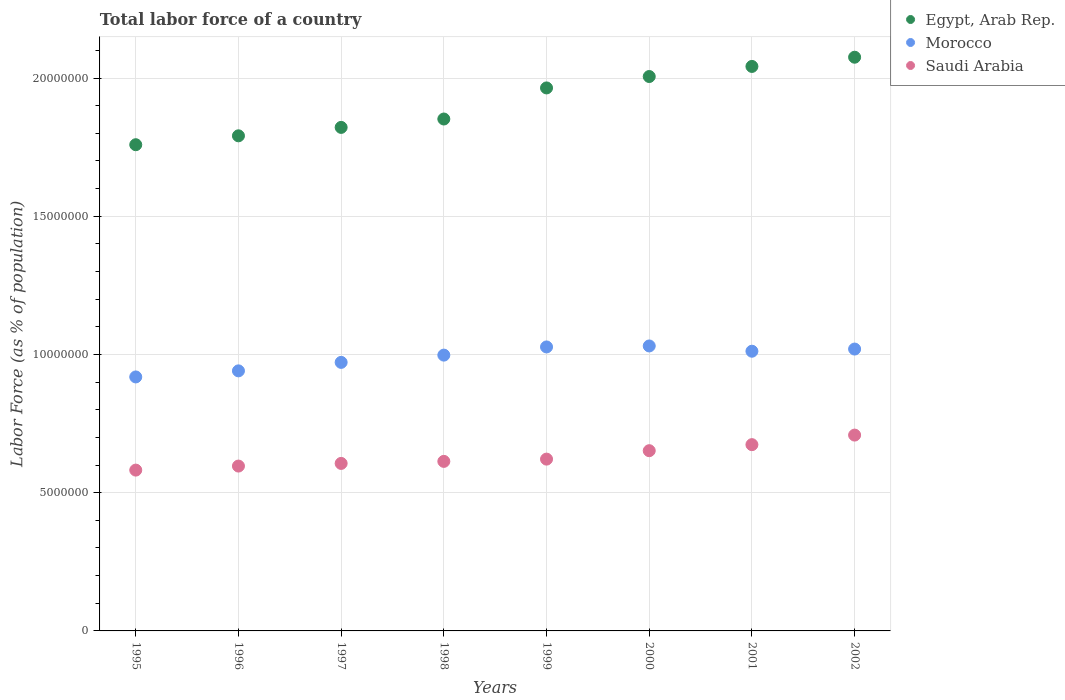What is the percentage of labor force in Saudi Arabia in 2002?
Your answer should be compact. 7.08e+06. Across all years, what is the maximum percentage of labor force in Saudi Arabia?
Make the answer very short. 7.08e+06. Across all years, what is the minimum percentage of labor force in Saudi Arabia?
Your answer should be very brief. 5.82e+06. In which year was the percentage of labor force in Egypt, Arab Rep. maximum?
Make the answer very short. 2002. What is the total percentage of labor force in Saudi Arabia in the graph?
Provide a short and direct response. 5.05e+07. What is the difference between the percentage of labor force in Morocco in 1999 and that in 2000?
Make the answer very short. -3.57e+04. What is the difference between the percentage of labor force in Morocco in 2002 and the percentage of labor force in Egypt, Arab Rep. in 1997?
Keep it short and to the point. -8.02e+06. What is the average percentage of labor force in Egypt, Arab Rep. per year?
Your answer should be very brief. 1.91e+07. In the year 2001, what is the difference between the percentage of labor force in Saudi Arabia and percentage of labor force in Morocco?
Your response must be concise. -3.38e+06. In how many years, is the percentage of labor force in Morocco greater than 1000000 %?
Your answer should be very brief. 8. What is the ratio of the percentage of labor force in Saudi Arabia in 1998 to that in 2002?
Make the answer very short. 0.87. Is the percentage of labor force in Morocco in 2000 less than that in 2002?
Provide a short and direct response. No. What is the difference between the highest and the second highest percentage of labor force in Morocco?
Offer a terse response. 3.57e+04. What is the difference between the highest and the lowest percentage of labor force in Saudi Arabia?
Provide a short and direct response. 1.27e+06. In how many years, is the percentage of labor force in Egypt, Arab Rep. greater than the average percentage of labor force in Egypt, Arab Rep. taken over all years?
Provide a short and direct response. 4. Is it the case that in every year, the sum of the percentage of labor force in Egypt, Arab Rep. and percentage of labor force in Morocco  is greater than the percentage of labor force in Saudi Arabia?
Give a very brief answer. Yes. Does the percentage of labor force in Morocco monotonically increase over the years?
Provide a succinct answer. No. Is the percentage of labor force in Egypt, Arab Rep. strictly less than the percentage of labor force in Morocco over the years?
Keep it short and to the point. No. How many dotlines are there?
Offer a terse response. 3. Are the values on the major ticks of Y-axis written in scientific E-notation?
Ensure brevity in your answer.  No. Does the graph contain any zero values?
Give a very brief answer. No. Does the graph contain grids?
Your response must be concise. Yes. Where does the legend appear in the graph?
Offer a terse response. Top right. What is the title of the graph?
Provide a succinct answer. Total labor force of a country. What is the label or title of the Y-axis?
Offer a very short reply. Labor Force (as % of population). What is the Labor Force (as % of population) of Egypt, Arab Rep. in 1995?
Provide a succinct answer. 1.76e+07. What is the Labor Force (as % of population) in Morocco in 1995?
Offer a terse response. 9.19e+06. What is the Labor Force (as % of population) of Saudi Arabia in 1995?
Offer a terse response. 5.82e+06. What is the Labor Force (as % of population) in Egypt, Arab Rep. in 1996?
Ensure brevity in your answer.  1.79e+07. What is the Labor Force (as % of population) of Morocco in 1996?
Offer a terse response. 9.41e+06. What is the Labor Force (as % of population) of Saudi Arabia in 1996?
Offer a very short reply. 5.96e+06. What is the Labor Force (as % of population) in Egypt, Arab Rep. in 1997?
Keep it short and to the point. 1.82e+07. What is the Labor Force (as % of population) of Morocco in 1997?
Provide a short and direct response. 9.71e+06. What is the Labor Force (as % of population) of Saudi Arabia in 1997?
Keep it short and to the point. 6.06e+06. What is the Labor Force (as % of population) in Egypt, Arab Rep. in 1998?
Give a very brief answer. 1.85e+07. What is the Labor Force (as % of population) of Morocco in 1998?
Provide a succinct answer. 9.98e+06. What is the Labor Force (as % of population) in Saudi Arabia in 1998?
Provide a succinct answer. 6.13e+06. What is the Labor Force (as % of population) in Egypt, Arab Rep. in 1999?
Your answer should be very brief. 1.96e+07. What is the Labor Force (as % of population) in Morocco in 1999?
Keep it short and to the point. 1.03e+07. What is the Labor Force (as % of population) in Saudi Arabia in 1999?
Your response must be concise. 6.21e+06. What is the Labor Force (as % of population) of Egypt, Arab Rep. in 2000?
Your response must be concise. 2.01e+07. What is the Labor Force (as % of population) of Morocco in 2000?
Offer a terse response. 1.03e+07. What is the Labor Force (as % of population) of Saudi Arabia in 2000?
Keep it short and to the point. 6.52e+06. What is the Labor Force (as % of population) of Egypt, Arab Rep. in 2001?
Provide a succinct answer. 2.04e+07. What is the Labor Force (as % of population) of Morocco in 2001?
Offer a very short reply. 1.01e+07. What is the Labor Force (as % of population) in Saudi Arabia in 2001?
Offer a very short reply. 6.74e+06. What is the Labor Force (as % of population) of Egypt, Arab Rep. in 2002?
Offer a very short reply. 2.08e+07. What is the Labor Force (as % of population) in Morocco in 2002?
Offer a terse response. 1.02e+07. What is the Labor Force (as % of population) of Saudi Arabia in 2002?
Your answer should be very brief. 7.08e+06. Across all years, what is the maximum Labor Force (as % of population) in Egypt, Arab Rep.?
Offer a terse response. 2.08e+07. Across all years, what is the maximum Labor Force (as % of population) of Morocco?
Keep it short and to the point. 1.03e+07. Across all years, what is the maximum Labor Force (as % of population) of Saudi Arabia?
Keep it short and to the point. 7.08e+06. Across all years, what is the minimum Labor Force (as % of population) in Egypt, Arab Rep.?
Provide a short and direct response. 1.76e+07. Across all years, what is the minimum Labor Force (as % of population) in Morocco?
Your answer should be very brief. 9.19e+06. Across all years, what is the minimum Labor Force (as % of population) in Saudi Arabia?
Your response must be concise. 5.82e+06. What is the total Labor Force (as % of population) in Egypt, Arab Rep. in the graph?
Your answer should be very brief. 1.53e+08. What is the total Labor Force (as % of population) in Morocco in the graph?
Provide a short and direct response. 7.92e+07. What is the total Labor Force (as % of population) in Saudi Arabia in the graph?
Provide a short and direct response. 5.05e+07. What is the difference between the Labor Force (as % of population) in Egypt, Arab Rep. in 1995 and that in 1996?
Give a very brief answer. -3.22e+05. What is the difference between the Labor Force (as % of population) of Morocco in 1995 and that in 1996?
Give a very brief answer. -2.20e+05. What is the difference between the Labor Force (as % of population) in Saudi Arabia in 1995 and that in 1996?
Provide a short and direct response. -1.46e+05. What is the difference between the Labor Force (as % of population) of Egypt, Arab Rep. in 1995 and that in 1997?
Give a very brief answer. -6.27e+05. What is the difference between the Labor Force (as % of population) in Morocco in 1995 and that in 1997?
Make the answer very short. -5.27e+05. What is the difference between the Labor Force (as % of population) of Saudi Arabia in 1995 and that in 1997?
Your answer should be very brief. -2.42e+05. What is the difference between the Labor Force (as % of population) in Egypt, Arab Rep. in 1995 and that in 1998?
Your answer should be very brief. -9.30e+05. What is the difference between the Labor Force (as % of population) of Morocco in 1995 and that in 1998?
Your answer should be very brief. -7.89e+05. What is the difference between the Labor Force (as % of population) in Saudi Arabia in 1995 and that in 1998?
Your answer should be compact. -3.16e+05. What is the difference between the Labor Force (as % of population) in Egypt, Arab Rep. in 1995 and that in 1999?
Your answer should be compact. -2.05e+06. What is the difference between the Labor Force (as % of population) in Morocco in 1995 and that in 1999?
Offer a very short reply. -1.08e+06. What is the difference between the Labor Force (as % of population) of Saudi Arabia in 1995 and that in 1999?
Your response must be concise. -3.97e+05. What is the difference between the Labor Force (as % of population) of Egypt, Arab Rep. in 1995 and that in 2000?
Offer a very short reply. -2.47e+06. What is the difference between the Labor Force (as % of population) of Morocco in 1995 and that in 2000?
Your answer should be very brief. -1.12e+06. What is the difference between the Labor Force (as % of population) of Saudi Arabia in 1995 and that in 2000?
Your answer should be compact. -7.02e+05. What is the difference between the Labor Force (as % of population) of Egypt, Arab Rep. in 1995 and that in 2001?
Ensure brevity in your answer.  -2.83e+06. What is the difference between the Labor Force (as % of population) of Morocco in 1995 and that in 2001?
Offer a terse response. -9.30e+05. What is the difference between the Labor Force (as % of population) in Saudi Arabia in 1995 and that in 2001?
Give a very brief answer. -9.21e+05. What is the difference between the Labor Force (as % of population) in Egypt, Arab Rep. in 1995 and that in 2002?
Your answer should be compact. -3.17e+06. What is the difference between the Labor Force (as % of population) in Morocco in 1995 and that in 2002?
Your answer should be very brief. -1.01e+06. What is the difference between the Labor Force (as % of population) of Saudi Arabia in 1995 and that in 2002?
Your answer should be very brief. -1.27e+06. What is the difference between the Labor Force (as % of population) in Egypt, Arab Rep. in 1996 and that in 1997?
Keep it short and to the point. -3.05e+05. What is the difference between the Labor Force (as % of population) of Morocco in 1996 and that in 1997?
Offer a very short reply. -3.07e+05. What is the difference between the Labor Force (as % of population) in Saudi Arabia in 1996 and that in 1997?
Provide a succinct answer. -9.58e+04. What is the difference between the Labor Force (as % of population) in Egypt, Arab Rep. in 1996 and that in 1998?
Provide a short and direct response. -6.08e+05. What is the difference between the Labor Force (as % of population) of Morocco in 1996 and that in 1998?
Give a very brief answer. -5.70e+05. What is the difference between the Labor Force (as % of population) in Saudi Arabia in 1996 and that in 1998?
Your answer should be compact. -1.69e+05. What is the difference between the Labor Force (as % of population) in Egypt, Arab Rep. in 1996 and that in 1999?
Keep it short and to the point. -1.73e+06. What is the difference between the Labor Force (as % of population) of Morocco in 1996 and that in 1999?
Keep it short and to the point. -8.65e+05. What is the difference between the Labor Force (as % of population) of Saudi Arabia in 1996 and that in 1999?
Offer a very short reply. -2.51e+05. What is the difference between the Labor Force (as % of population) of Egypt, Arab Rep. in 1996 and that in 2000?
Offer a very short reply. -2.14e+06. What is the difference between the Labor Force (as % of population) of Morocco in 1996 and that in 2000?
Your answer should be compact. -9.01e+05. What is the difference between the Labor Force (as % of population) in Saudi Arabia in 1996 and that in 2000?
Provide a short and direct response. -5.56e+05. What is the difference between the Labor Force (as % of population) of Egypt, Arab Rep. in 1996 and that in 2001?
Offer a terse response. -2.51e+06. What is the difference between the Labor Force (as % of population) of Morocco in 1996 and that in 2001?
Provide a short and direct response. -7.10e+05. What is the difference between the Labor Force (as % of population) of Saudi Arabia in 1996 and that in 2001?
Provide a succinct answer. -7.75e+05. What is the difference between the Labor Force (as % of population) of Egypt, Arab Rep. in 1996 and that in 2002?
Provide a succinct answer. -2.84e+06. What is the difference between the Labor Force (as % of population) of Morocco in 1996 and that in 2002?
Make the answer very short. -7.89e+05. What is the difference between the Labor Force (as % of population) of Saudi Arabia in 1996 and that in 2002?
Make the answer very short. -1.12e+06. What is the difference between the Labor Force (as % of population) in Egypt, Arab Rep. in 1997 and that in 1998?
Ensure brevity in your answer.  -3.03e+05. What is the difference between the Labor Force (as % of population) in Morocco in 1997 and that in 1998?
Offer a terse response. -2.63e+05. What is the difference between the Labor Force (as % of population) in Saudi Arabia in 1997 and that in 1998?
Your answer should be compact. -7.36e+04. What is the difference between the Labor Force (as % of population) in Egypt, Arab Rep. in 1997 and that in 1999?
Your answer should be very brief. -1.43e+06. What is the difference between the Labor Force (as % of population) in Morocco in 1997 and that in 1999?
Give a very brief answer. -5.58e+05. What is the difference between the Labor Force (as % of population) in Saudi Arabia in 1997 and that in 1999?
Make the answer very short. -1.55e+05. What is the difference between the Labor Force (as % of population) of Egypt, Arab Rep. in 1997 and that in 2000?
Make the answer very short. -1.84e+06. What is the difference between the Labor Force (as % of population) of Morocco in 1997 and that in 2000?
Your answer should be very brief. -5.94e+05. What is the difference between the Labor Force (as % of population) in Saudi Arabia in 1997 and that in 2000?
Keep it short and to the point. -4.60e+05. What is the difference between the Labor Force (as % of population) in Egypt, Arab Rep. in 1997 and that in 2001?
Offer a terse response. -2.21e+06. What is the difference between the Labor Force (as % of population) in Morocco in 1997 and that in 2001?
Offer a terse response. -4.04e+05. What is the difference between the Labor Force (as % of population) in Saudi Arabia in 1997 and that in 2001?
Your answer should be compact. -6.79e+05. What is the difference between the Labor Force (as % of population) in Egypt, Arab Rep. in 1997 and that in 2002?
Your answer should be very brief. -2.54e+06. What is the difference between the Labor Force (as % of population) in Morocco in 1997 and that in 2002?
Your answer should be very brief. -4.82e+05. What is the difference between the Labor Force (as % of population) in Saudi Arabia in 1997 and that in 2002?
Give a very brief answer. -1.02e+06. What is the difference between the Labor Force (as % of population) in Egypt, Arab Rep. in 1998 and that in 1999?
Provide a succinct answer. -1.12e+06. What is the difference between the Labor Force (as % of population) of Morocco in 1998 and that in 1999?
Offer a very short reply. -2.95e+05. What is the difference between the Labor Force (as % of population) in Saudi Arabia in 1998 and that in 1999?
Your answer should be compact. -8.19e+04. What is the difference between the Labor Force (as % of population) in Egypt, Arab Rep. in 1998 and that in 2000?
Your answer should be compact. -1.54e+06. What is the difference between the Labor Force (as % of population) of Morocco in 1998 and that in 2000?
Make the answer very short. -3.31e+05. What is the difference between the Labor Force (as % of population) of Saudi Arabia in 1998 and that in 2000?
Your answer should be very brief. -3.87e+05. What is the difference between the Labor Force (as % of population) of Egypt, Arab Rep. in 1998 and that in 2001?
Provide a succinct answer. -1.90e+06. What is the difference between the Labor Force (as % of population) in Morocco in 1998 and that in 2001?
Offer a terse response. -1.41e+05. What is the difference between the Labor Force (as % of population) in Saudi Arabia in 1998 and that in 2001?
Offer a terse response. -6.05e+05. What is the difference between the Labor Force (as % of population) of Egypt, Arab Rep. in 1998 and that in 2002?
Your response must be concise. -2.24e+06. What is the difference between the Labor Force (as % of population) of Morocco in 1998 and that in 2002?
Provide a short and direct response. -2.19e+05. What is the difference between the Labor Force (as % of population) of Saudi Arabia in 1998 and that in 2002?
Provide a succinct answer. -9.51e+05. What is the difference between the Labor Force (as % of population) in Egypt, Arab Rep. in 1999 and that in 2000?
Your response must be concise. -4.13e+05. What is the difference between the Labor Force (as % of population) in Morocco in 1999 and that in 2000?
Give a very brief answer. -3.57e+04. What is the difference between the Labor Force (as % of population) of Saudi Arabia in 1999 and that in 2000?
Offer a very short reply. -3.05e+05. What is the difference between the Labor Force (as % of population) in Egypt, Arab Rep. in 1999 and that in 2001?
Offer a terse response. -7.78e+05. What is the difference between the Labor Force (as % of population) in Morocco in 1999 and that in 2001?
Make the answer very short. 1.55e+05. What is the difference between the Labor Force (as % of population) of Saudi Arabia in 1999 and that in 2001?
Make the answer very short. -5.23e+05. What is the difference between the Labor Force (as % of population) in Egypt, Arab Rep. in 1999 and that in 2002?
Provide a succinct answer. -1.11e+06. What is the difference between the Labor Force (as % of population) of Morocco in 1999 and that in 2002?
Your answer should be very brief. 7.62e+04. What is the difference between the Labor Force (as % of population) of Saudi Arabia in 1999 and that in 2002?
Your response must be concise. -8.69e+05. What is the difference between the Labor Force (as % of population) in Egypt, Arab Rep. in 2000 and that in 2001?
Your answer should be very brief. -3.65e+05. What is the difference between the Labor Force (as % of population) of Morocco in 2000 and that in 2001?
Keep it short and to the point. 1.90e+05. What is the difference between the Labor Force (as % of population) in Saudi Arabia in 2000 and that in 2001?
Give a very brief answer. -2.18e+05. What is the difference between the Labor Force (as % of population) in Egypt, Arab Rep. in 2000 and that in 2002?
Give a very brief answer. -6.98e+05. What is the difference between the Labor Force (as % of population) in Morocco in 2000 and that in 2002?
Ensure brevity in your answer.  1.12e+05. What is the difference between the Labor Force (as % of population) of Saudi Arabia in 2000 and that in 2002?
Your answer should be compact. -5.64e+05. What is the difference between the Labor Force (as % of population) in Egypt, Arab Rep. in 2001 and that in 2002?
Provide a short and direct response. -3.33e+05. What is the difference between the Labor Force (as % of population) in Morocco in 2001 and that in 2002?
Provide a succinct answer. -7.84e+04. What is the difference between the Labor Force (as % of population) in Saudi Arabia in 2001 and that in 2002?
Your response must be concise. -3.46e+05. What is the difference between the Labor Force (as % of population) in Egypt, Arab Rep. in 1995 and the Labor Force (as % of population) in Morocco in 1996?
Ensure brevity in your answer.  8.18e+06. What is the difference between the Labor Force (as % of population) in Egypt, Arab Rep. in 1995 and the Labor Force (as % of population) in Saudi Arabia in 1996?
Provide a short and direct response. 1.16e+07. What is the difference between the Labor Force (as % of population) in Morocco in 1995 and the Labor Force (as % of population) in Saudi Arabia in 1996?
Provide a succinct answer. 3.22e+06. What is the difference between the Labor Force (as % of population) in Egypt, Arab Rep. in 1995 and the Labor Force (as % of population) in Morocco in 1997?
Offer a terse response. 7.87e+06. What is the difference between the Labor Force (as % of population) of Egypt, Arab Rep. in 1995 and the Labor Force (as % of population) of Saudi Arabia in 1997?
Ensure brevity in your answer.  1.15e+07. What is the difference between the Labor Force (as % of population) in Morocco in 1995 and the Labor Force (as % of population) in Saudi Arabia in 1997?
Make the answer very short. 3.13e+06. What is the difference between the Labor Force (as % of population) in Egypt, Arab Rep. in 1995 and the Labor Force (as % of population) in Morocco in 1998?
Ensure brevity in your answer.  7.61e+06. What is the difference between the Labor Force (as % of population) of Egypt, Arab Rep. in 1995 and the Labor Force (as % of population) of Saudi Arabia in 1998?
Provide a short and direct response. 1.15e+07. What is the difference between the Labor Force (as % of population) of Morocco in 1995 and the Labor Force (as % of population) of Saudi Arabia in 1998?
Your answer should be very brief. 3.05e+06. What is the difference between the Labor Force (as % of population) in Egypt, Arab Rep. in 1995 and the Labor Force (as % of population) in Morocco in 1999?
Provide a succinct answer. 7.32e+06. What is the difference between the Labor Force (as % of population) of Egypt, Arab Rep. in 1995 and the Labor Force (as % of population) of Saudi Arabia in 1999?
Your answer should be compact. 1.14e+07. What is the difference between the Labor Force (as % of population) of Morocco in 1995 and the Labor Force (as % of population) of Saudi Arabia in 1999?
Your response must be concise. 2.97e+06. What is the difference between the Labor Force (as % of population) in Egypt, Arab Rep. in 1995 and the Labor Force (as % of population) in Morocco in 2000?
Ensure brevity in your answer.  7.28e+06. What is the difference between the Labor Force (as % of population) of Egypt, Arab Rep. in 1995 and the Labor Force (as % of population) of Saudi Arabia in 2000?
Provide a short and direct response. 1.11e+07. What is the difference between the Labor Force (as % of population) of Morocco in 1995 and the Labor Force (as % of population) of Saudi Arabia in 2000?
Make the answer very short. 2.67e+06. What is the difference between the Labor Force (as % of population) in Egypt, Arab Rep. in 1995 and the Labor Force (as % of population) in Morocco in 2001?
Offer a very short reply. 7.47e+06. What is the difference between the Labor Force (as % of population) in Egypt, Arab Rep. in 1995 and the Labor Force (as % of population) in Saudi Arabia in 2001?
Ensure brevity in your answer.  1.09e+07. What is the difference between the Labor Force (as % of population) in Morocco in 1995 and the Labor Force (as % of population) in Saudi Arabia in 2001?
Ensure brevity in your answer.  2.45e+06. What is the difference between the Labor Force (as % of population) of Egypt, Arab Rep. in 1995 and the Labor Force (as % of population) of Morocco in 2002?
Give a very brief answer. 7.39e+06. What is the difference between the Labor Force (as % of population) in Egypt, Arab Rep. in 1995 and the Labor Force (as % of population) in Saudi Arabia in 2002?
Give a very brief answer. 1.05e+07. What is the difference between the Labor Force (as % of population) of Morocco in 1995 and the Labor Force (as % of population) of Saudi Arabia in 2002?
Give a very brief answer. 2.10e+06. What is the difference between the Labor Force (as % of population) of Egypt, Arab Rep. in 1996 and the Labor Force (as % of population) of Morocco in 1997?
Provide a succinct answer. 8.20e+06. What is the difference between the Labor Force (as % of population) in Egypt, Arab Rep. in 1996 and the Labor Force (as % of population) in Saudi Arabia in 1997?
Offer a terse response. 1.19e+07. What is the difference between the Labor Force (as % of population) of Morocco in 1996 and the Labor Force (as % of population) of Saudi Arabia in 1997?
Ensure brevity in your answer.  3.35e+06. What is the difference between the Labor Force (as % of population) of Egypt, Arab Rep. in 1996 and the Labor Force (as % of population) of Morocco in 1998?
Provide a short and direct response. 7.93e+06. What is the difference between the Labor Force (as % of population) in Egypt, Arab Rep. in 1996 and the Labor Force (as % of population) in Saudi Arabia in 1998?
Make the answer very short. 1.18e+07. What is the difference between the Labor Force (as % of population) of Morocco in 1996 and the Labor Force (as % of population) of Saudi Arabia in 1998?
Offer a terse response. 3.27e+06. What is the difference between the Labor Force (as % of population) in Egypt, Arab Rep. in 1996 and the Labor Force (as % of population) in Morocco in 1999?
Your answer should be compact. 7.64e+06. What is the difference between the Labor Force (as % of population) in Egypt, Arab Rep. in 1996 and the Labor Force (as % of population) in Saudi Arabia in 1999?
Provide a succinct answer. 1.17e+07. What is the difference between the Labor Force (as % of population) of Morocco in 1996 and the Labor Force (as % of population) of Saudi Arabia in 1999?
Provide a succinct answer. 3.19e+06. What is the difference between the Labor Force (as % of population) in Egypt, Arab Rep. in 1996 and the Labor Force (as % of population) in Morocco in 2000?
Your answer should be very brief. 7.60e+06. What is the difference between the Labor Force (as % of population) of Egypt, Arab Rep. in 1996 and the Labor Force (as % of population) of Saudi Arabia in 2000?
Your answer should be compact. 1.14e+07. What is the difference between the Labor Force (as % of population) of Morocco in 1996 and the Labor Force (as % of population) of Saudi Arabia in 2000?
Your answer should be very brief. 2.89e+06. What is the difference between the Labor Force (as % of population) in Egypt, Arab Rep. in 1996 and the Labor Force (as % of population) in Morocco in 2001?
Provide a succinct answer. 7.79e+06. What is the difference between the Labor Force (as % of population) in Egypt, Arab Rep. in 1996 and the Labor Force (as % of population) in Saudi Arabia in 2001?
Your response must be concise. 1.12e+07. What is the difference between the Labor Force (as % of population) in Morocco in 1996 and the Labor Force (as % of population) in Saudi Arabia in 2001?
Make the answer very short. 2.67e+06. What is the difference between the Labor Force (as % of population) of Egypt, Arab Rep. in 1996 and the Labor Force (as % of population) of Morocco in 2002?
Your answer should be very brief. 7.71e+06. What is the difference between the Labor Force (as % of population) of Egypt, Arab Rep. in 1996 and the Labor Force (as % of population) of Saudi Arabia in 2002?
Your response must be concise. 1.08e+07. What is the difference between the Labor Force (as % of population) in Morocco in 1996 and the Labor Force (as % of population) in Saudi Arabia in 2002?
Provide a succinct answer. 2.32e+06. What is the difference between the Labor Force (as % of population) in Egypt, Arab Rep. in 1997 and the Labor Force (as % of population) in Morocco in 1998?
Your answer should be compact. 8.24e+06. What is the difference between the Labor Force (as % of population) of Egypt, Arab Rep. in 1997 and the Labor Force (as % of population) of Saudi Arabia in 1998?
Make the answer very short. 1.21e+07. What is the difference between the Labor Force (as % of population) of Morocco in 1997 and the Labor Force (as % of population) of Saudi Arabia in 1998?
Keep it short and to the point. 3.58e+06. What is the difference between the Labor Force (as % of population) of Egypt, Arab Rep. in 1997 and the Labor Force (as % of population) of Morocco in 1999?
Provide a succinct answer. 7.94e+06. What is the difference between the Labor Force (as % of population) of Egypt, Arab Rep. in 1997 and the Labor Force (as % of population) of Saudi Arabia in 1999?
Provide a short and direct response. 1.20e+07. What is the difference between the Labor Force (as % of population) of Morocco in 1997 and the Labor Force (as % of population) of Saudi Arabia in 1999?
Provide a short and direct response. 3.50e+06. What is the difference between the Labor Force (as % of population) of Egypt, Arab Rep. in 1997 and the Labor Force (as % of population) of Morocco in 2000?
Provide a succinct answer. 7.91e+06. What is the difference between the Labor Force (as % of population) of Egypt, Arab Rep. in 1997 and the Labor Force (as % of population) of Saudi Arabia in 2000?
Ensure brevity in your answer.  1.17e+07. What is the difference between the Labor Force (as % of population) in Morocco in 1997 and the Labor Force (as % of population) in Saudi Arabia in 2000?
Your response must be concise. 3.19e+06. What is the difference between the Labor Force (as % of population) of Egypt, Arab Rep. in 1997 and the Labor Force (as % of population) of Morocco in 2001?
Provide a short and direct response. 8.10e+06. What is the difference between the Labor Force (as % of population) of Egypt, Arab Rep. in 1997 and the Labor Force (as % of population) of Saudi Arabia in 2001?
Offer a terse response. 1.15e+07. What is the difference between the Labor Force (as % of population) in Morocco in 1997 and the Labor Force (as % of population) in Saudi Arabia in 2001?
Make the answer very short. 2.98e+06. What is the difference between the Labor Force (as % of population) in Egypt, Arab Rep. in 1997 and the Labor Force (as % of population) in Morocco in 2002?
Offer a terse response. 8.02e+06. What is the difference between the Labor Force (as % of population) in Egypt, Arab Rep. in 1997 and the Labor Force (as % of population) in Saudi Arabia in 2002?
Your answer should be compact. 1.11e+07. What is the difference between the Labor Force (as % of population) in Morocco in 1997 and the Labor Force (as % of population) in Saudi Arabia in 2002?
Your answer should be compact. 2.63e+06. What is the difference between the Labor Force (as % of population) in Egypt, Arab Rep. in 1998 and the Labor Force (as % of population) in Morocco in 1999?
Ensure brevity in your answer.  8.25e+06. What is the difference between the Labor Force (as % of population) of Egypt, Arab Rep. in 1998 and the Labor Force (as % of population) of Saudi Arabia in 1999?
Your answer should be compact. 1.23e+07. What is the difference between the Labor Force (as % of population) in Morocco in 1998 and the Labor Force (as % of population) in Saudi Arabia in 1999?
Provide a succinct answer. 3.76e+06. What is the difference between the Labor Force (as % of population) in Egypt, Arab Rep. in 1998 and the Labor Force (as % of population) in Morocco in 2000?
Your response must be concise. 8.21e+06. What is the difference between the Labor Force (as % of population) in Egypt, Arab Rep. in 1998 and the Labor Force (as % of population) in Saudi Arabia in 2000?
Provide a short and direct response. 1.20e+07. What is the difference between the Labor Force (as % of population) in Morocco in 1998 and the Labor Force (as % of population) in Saudi Arabia in 2000?
Your answer should be very brief. 3.46e+06. What is the difference between the Labor Force (as % of population) in Egypt, Arab Rep. in 1998 and the Labor Force (as % of population) in Morocco in 2001?
Offer a very short reply. 8.40e+06. What is the difference between the Labor Force (as % of population) in Egypt, Arab Rep. in 1998 and the Labor Force (as % of population) in Saudi Arabia in 2001?
Ensure brevity in your answer.  1.18e+07. What is the difference between the Labor Force (as % of population) in Morocco in 1998 and the Labor Force (as % of population) in Saudi Arabia in 2001?
Offer a very short reply. 3.24e+06. What is the difference between the Labor Force (as % of population) of Egypt, Arab Rep. in 1998 and the Labor Force (as % of population) of Morocco in 2002?
Make the answer very short. 8.32e+06. What is the difference between the Labor Force (as % of population) of Egypt, Arab Rep. in 1998 and the Labor Force (as % of population) of Saudi Arabia in 2002?
Offer a terse response. 1.14e+07. What is the difference between the Labor Force (as % of population) in Morocco in 1998 and the Labor Force (as % of population) in Saudi Arabia in 2002?
Make the answer very short. 2.89e+06. What is the difference between the Labor Force (as % of population) in Egypt, Arab Rep. in 1999 and the Labor Force (as % of population) in Morocco in 2000?
Give a very brief answer. 9.33e+06. What is the difference between the Labor Force (as % of population) of Egypt, Arab Rep. in 1999 and the Labor Force (as % of population) of Saudi Arabia in 2000?
Make the answer very short. 1.31e+07. What is the difference between the Labor Force (as % of population) in Morocco in 1999 and the Labor Force (as % of population) in Saudi Arabia in 2000?
Provide a succinct answer. 3.75e+06. What is the difference between the Labor Force (as % of population) in Egypt, Arab Rep. in 1999 and the Labor Force (as % of population) in Morocco in 2001?
Give a very brief answer. 9.52e+06. What is the difference between the Labor Force (as % of population) of Egypt, Arab Rep. in 1999 and the Labor Force (as % of population) of Saudi Arabia in 2001?
Provide a short and direct response. 1.29e+07. What is the difference between the Labor Force (as % of population) in Morocco in 1999 and the Labor Force (as % of population) in Saudi Arabia in 2001?
Your response must be concise. 3.53e+06. What is the difference between the Labor Force (as % of population) in Egypt, Arab Rep. in 1999 and the Labor Force (as % of population) in Morocco in 2002?
Give a very brief answer. 9.45e+06. What is the difference between the Labor Force (as % of population) in Egypt, Arab Rep. in 1999 and the Labor Force (as % of population) in Saudi Arabia in 2002?
Ensure brevity in your answer.  1.26e+07. What is the difference between the Labor Force (as % of population) in Morocco in 1999 and the Labor Force (as % of population) in Saudi Arabia in 2002?
Make the answer very short. 3.19e+06. What is the difference between the Labor Force (as % of population) in Egypt, Arab Rep. in 2000 and the Labor Force (as % of population) in Morocco in 2001?
Offer a terse response. 9.94e+06. What is the difference between the Labor Force (as % of population) of Egypt, Arab Rep. in 2000 and the Labor Force (as % of population) of Saudi Arabia in 2001?
Keep it short and to the point. 1.33e+07. What is the difference between the Labor Force (as % of population) in Morocco in 2000 and the Labor Force (as % of population) in Saudi Arabia in 2001?
Give a very brief answer. 3.57e+06. What is the difference between the Labor Force (as % of population) in Egypt, Arab Rep. in 2000 and the Labor Force (as % of population) in Morocco in 2002?
Your response must be concise. 9.86e+06. What is the difference between the Labor Force (as % of population) of Egypt, Arab Rep. in 2000 and the Labor Force (as % of population) of Saudi Arabia in 2002?
Your answer should be very brief. 1.30e+07. What is the difference between the Labor Force (as % of population) of Morocco in 2000 and the Labor Force (as % of population) of Saudi Arabia in 2002?
Your answer should be very brief. 3.22e+06. What is the difference between the Labor Force (as % of population) in Egypt, Arab Rep. in 2001 and the Labor Force (as % of population) in Morocco in 2002?
Provide a short and direct response. 1.02e+07. What is the difference between the Labor Force (as % of population) in Egypt, Arab Rep. in 2001 and the Labor Force (as % of population) in Saudi Arabia in 2002?
Provide a succinct answer. 1.33e+07. What is the difference between the Labor Force (as % of population) in Morocco in 2001 and the Labor Force (as % of population) in Saudi Arabia in 2002?
Your answer should be very brief. 3.03e+06. What is the average Labor Force (as % of population) of Egypt, Arab Rep. per year?
Keep it short and to the point. 1.91e+07. What is the average Labor Force (as % of population) of Morocco per year?
Provide a succinct answer. 9.90e+06. What is the average Labor Force (as % of population) in Saudi Arabia per year?
Ensure brevity in your answer.  6.32e+06. In the year 1995, what is the difference between the Labor Force (as % of population) in Egypt, Arab Rep. and Labor Force (as % of population) in Morocco?
Give a very brief answer. 8.40e+06. In the year 1995, what is the difference between the Labor Force (as % of population) of Egypt, Arab Rep. and Labor Force (as % of population) of Saudi Arabia?
Keep it short and to the point. 1.18e+07. In the year 1995, what is the difference between the Labor Force (as % of population) in Morocco and Labor Force (as % of population) in Saudi Arabia?
Your response must be concise. 3.37e+06. In the year 1996, what is the difference between the Labor Force (as % of population) of Egypt, Arab Rep. and Labor Force (as % of population) of Morocco?
Offer a very short reply. 8.50e+06. In the year 1996, what is the difference between the Labor Force (as % of population) in Egypt, Arab Rep. and Labor Force (as % of population) in Saudi Arabia?
Offer a very short reply. 1.19e+07. In the year 1996, what is the difference between the Labor Force (as % of population) of Morocco and Labor Force (as % of population) of Saudi Arabia?
Give a very brief answer. 3.44e+06. In the year 1997, what is the difference between the Labor Force (as % of population) of Egypt, Arab Rep. and Labor Force (as % of population) of Morocco?
Give a very brief answer. 8.50e+06. In the year 1997, what is the difference between the Labor Force (as % of population) of Egypt, Arab Rep. and Labor Force (as % of population) of Saudi Arabia?
Offer a terse response. 1.22e+07. In the year 1997, what is the difference between the Labor Force (as % of population) in Morocco and Labor Force (as % of population) in Saudi Arabia?
Provide a succinct answer. 3.66e+06. In the year 1998, what is the difference between the Labor Force (as % of population) of Egypt, Arab Rep. and Labor Force (as % of population) of Morocco?
Ensure brevity in your answer.  8.54e+06. In the year 1998, what is the difference between the Labor Force (as % of population) of Egypt, Arab Rep. and Labor Force (as % of population) of Saudi Arabia?
Provide a succinct answer. 1.24e+07. In the year 1998, what is the difference between the Labor Force (as % of population) in Morocco and Labor Force (as % of population) in Saudi Arabia?
Keep it short and to the point. 3.84e+06. In the year 1999, what is the difference between the Labor Force (as % of population) of Egypt, Arab Rep. and Labor Force (as % of population) of Morocco?
Make the answer very short. 9.37e+06. In the year 1999, what is the difference between the Labor Force (as % of population) of Egypt, Arab Rep. and Labor Force (as % of population) of Saudi Arabia?
Keep it short and to the point. 1.34e+07. In the year 1999, what is the difference between the Labor Force (as % of population) of Morocco and Labor Force (as % of population) of Saudi Arabia?
Your response must be concise. 4.06e+06. In the year 2000, what is the difference between the Labor Force (as % of population) in Egypt, Arab Rep. and Labor Force (as % of population) in Morocco?
Offer a terse response. 9.75e+06. In the year 2000, what is the difference between the Labor Force (as % of population) in Egypt, Arab Rep. and Labor Force (as % of population) in Saudi Arabia?
Give a very brief answer. 1.35e+07. In the year 2000, what is the difference between the Labor Force (as % of population) of Morocco and Labor Force (as % of population) of Saudi Arabia?
Your answer should be very brief. 3.79e+06. In the year 2001, what is the difference between the Labor Force (as % of population) in Egypt, Arab Rep. and Labor Force (as % of population) in Morocco?
Provide a short and direct response. 1.03e+07. In the year 2001, what is the difference between the Labor Force (as % of population) in Egypt, Arab Rep. and Labor Force (as % of population) in Saudi Arabia?
Make the answer very short. 1.37e+07. In the year 2001, what is the difference between the Labor Force (as % of population) in Morocco and Labor Force (as % of population) in Saudi Arabia?
Make the answer very short. 3.38e+06. In the year 2002, what is the difference between the Labor Force (as % of population) in Egypt, Arab Rep. and Labor Force (as % of population) in Morocco?
Ensure brevity in your answer.  1.06e+07. In the year 2002, what is the difference between the Labor Force (as % of population) in Egypt, Arab Rep. and Labor Force (as % of population) in Saudi Arabia?
Give a very brief answer. 1.37e+07. In the year 2002, what is the difference between the Labor Force (as % of population) of Morocco and Labor Force (as % of population) of Saudi Arabia?
Your response must be concise. 3.11e+06. What is the ratio of the Labor Force (as % of population) in Egypt, Arab Rep. in 1995 to that in 1996?
Provide a succinct answer. 0.98. What is the ratio of the Labor Force (as % of population) of Morocco in 1995 to that in 1996?
Keep it short and to the point. 0.98. What is the ratio of the Labor Force (as % of population) of Saudi Arabia in 1995 to that in 1996?
Ensure brevity in your answer.  0.98. What is the ratio of the Labor Force (as % of population) of Egypt, Arab Rep. in 1995 to that in 1997?
Your answer should be compact. 0.97. What is the ratio of the Labor Force (as % of population) of Morocco in 1995 to that in 1997?
Your answer should be compact. 0.95. What is the ratio of the Labor Force (as % of population) of Saudi Arabia in 1995 to that in 1997?
Offer a very short reply. 0.96. What is the ratio of the Labor Force (as % of population) of Egypt, Arab Rep. in 1995 to that in 1998?
Provide a succinct answer. 0.95. What is the ratio of the Labor Force (as % of population) in Morocco in 1995 to that in 1998?
Provide a succinct answer. 0.92. What is the ratio of the Labor Force (as % of population) in Saudi Arabia in 1995 to that in 1998?
Give a very brief answer. 0.95. What is the ratio of the Labor Force (as % of population) of Egypt, Arab Rep. in 1995 to that in 1999?
Provide a short and direct response. 0.9. What is the ratio of the Labor Force (as % of population) of Morocco in 1995 to that in 1999?
Provide a short and direct response. 0.89. What is the ratio of the Labor Force (as % of population) of Saudi Arabia in 1995 to that in 1999?
Make the answer very short. 0.94. What is the ratio of the Labor Force (as % of population) of Egypt, Arab Rep. in 1995 to that in 2000?
Offer a very short reply. 0.88. What is the ratio of the Labor Force (as % of population) in Morocco in 1995 to that in 2000?
Keep it short and to the point. 0.89. What is the ratio of the Labor Force (as % of population) in Saudi Arabia in 1995 to that in 2000?
Keep it short and to the point. 0.89. What is the ratio of the Labor Force (as % of population) of Egypt, Arab Rep. in 1995 to that in 2001?
Make the answer very short. 0.86. What is the ratio of the Labor Force (as % of population) in Morocco in 1995 to that in 2001?
Provide a succinct answer. 0.91. What is the ratio of the Labor Force (as % of population) in Saudi Arabia in 1995 to that in 2001?
Ensure brevity in your answer.  0.86. What is the ratio of the Labor Force (as % of population) of Egypt, Arab Rep. in 1995 to that in 2002?
Ensure brevity in your answer.  0.85. What is the ratio of the Labor Force (as % of population) of Morocco in 1995 to that in 2002?
Provide a short and direct response. 0.9. What is the ratio of the Labor Force (as % of population) in Saudi Arabia in 1995 to that in 2002?
Offer a very short reply. 0.82. What is the ratio of the Labor Force (as % of population) in Egypt, Arab Rep. in 1996 to that in 1997?
Give a very brief answer. 0.98. What is the ratio of the Labor Force (as % of population) of Morocco in 1996 to that in 1997?
Give a very brief answer. 0.97. What is the ratio of the Labor Force (as % of population) of Saudi Arabia in 1996 to that in 1997?
Your response must be concise. 0.98. What is the ratio of the Labor Force (as % of population) of Egypt, Arab Rep. in 1996 to that in 1998?
Your answer should be very brief. 0.97. What is the ratio of the Labor Force (as % of population) in Morocco in 1996 to that in 1998?
Provide a short and direct response. 0.94. What is the ratio of the Labor Force (as % of population) of Saudi Arabia in 1996 to that in 1998?
Give a very brief answer. 0.97. What is the ratio of the Labor Force (as % of population) in Egypt, Arab Rep. in 1996 to that in 1999?
Provide a short and direct response. 0.91. What is the ratio of the Labor Force (as % of population) in Morocco in 1996 to that in 1999?
Give a very brief answer. 0.92. What is the ratio of the Labor Force (as % of population) of Saudi Arabia in 1996 to that in 1999?
Make the answer very short. 0.96. What is the ratio of the Labor Force (as % of population) of Egypt, Arab Rep. in 1996 to that in 2000?
Provide a succinct answer. 0.89. What is the ratio of the Labor Force (as % of population) in Morocco in 1996 to that in 2000?
Provide a succinct answer. 0.91. What is the ratio of the Labor Force (as % of population) in Saudi Arabia in 1996 to that in 2000?
Provide a short and direct response. 0.91. What is the ratio of the Labor Force (as % of population) in Egypt, Arab Rep. in 1996 to that in 2001?
Provide a succinct answer. 0.88. What is the ratio of the Labor Force (as % of population) in Morocco in 1996 to that in 2001?
Offer a very short reply. 0.93. What is the ratio of the Labor Force (as % of population) in Saudi Arabia in 1996 to that in 2001?
Ensure brevity in your answer.  0.89. What is the ratio of the Labor Force (as % of population) in Egypt, Arab Rep. in 1996 to that in 2002?
Your answer should be compact. 0.86. What is the ratio of the Labor Force (as % of population) in Morocco in 1996 to that in 2002?
Provide a succinct answer. 0.92. What is the ratio of the Labor Force (as % of population) in Saudi Arabia in 1996 to that in 2002?
Your answer should be compact. 0.84. What is the ratio of the Labor Force (as % of population) in Egypt, Arab Rep. in 1997 to that in 1998?
Your answer should be very brief. 0.98. What is the ratio of the Labor Force (as % of population) in Morocco in 1997 to that in 1998?
Your answer should be very brief. 0.97. What is the ratio of the Labor Force (as % of population) of Egypt, Arab Rep. in 1997 to that in 1999?
Offer a very short reply. 0.93. What is the ratio of the Labor Force (as % of population) of Morocco in 1997 to that in 1999?
Your answer should be compact. 0.95. What is the ratio of the Labor Force (as % of population) of Saudi Arabia in 1997 to that in 1999?
Your answer should be very brief. 0.97. What is the ratio of the Labor Force (as % of population) of Egypt, Arab Rep. in 1997 to that in 2000?
Offer a very short reply. 0.91. What is the ratio of the Labor Force (as % of population) in Morocco in 1997 to that in 2000?
Offer a terse response. 0.94. What is the ratio of the Labor Force (as % of population) of Saudi Arabia in 1997 to that in 2000?
Your answer should be very brief. 0.93. What is the ratio of the Labor Force (as % of population) of Egypt, Arab Rep. in 1997 to that in 2001?
Your answer should be compact. 0.89. What is the ratio of the Labor Force (as % of population) in Morocco in 1997 to that in 2001?
Your answer should be compact. 0.96. What is the ratio of the Labor Force (as % of population) in Saudi Arabia in 1997 to that in 2001?
Make the answer very short. 0.9. What is the ratio of the Labor Force (as % of population) in Egypt, Arab Rep. in 1997 to that in 2002?
Provide a succinct answer. 0.88. What is the ratio of the Labor Force (as % of population) in Morocco in 1997 to that in 2002?
Your response must be concise. 0.95. What is the ratio of the Labor Force (as % of population) in Saudi Arabia in 1997 to that in 2002?
Offer a terse response. 0.86. What is the ratio of the Labor Force (as % of population) in Egypt, Arab Rep. in 1998 to that in 1999?
Give a very brief answer. 0.94. What is the ratio of the Labor Force (as % of population) in Morocco in 1998 to that in 1999?
Give a very brief answer. 0.97. What is the ratio of the Labor Force (as % of population) of Saudi Arabia in 1998 to that in 1999?
Your response must be concise. 0.99. What is the ratio of the Labor Force (as % of population) of Egypt, Arab Rep. in 1998 to that in 2000?
Keep it short and to the point. 0.92. What is the ratio of the Labor Force (as % of population) in Morocco in 1998 to that in 2000?
Ensure brevity in your answer.  0.97. What is the ratio of the Labor Force (as % of population) of Saudi Arabia in 1998 to that in 2000?
Provide a short and direct response. 0.94. What is the ratio of the Labor Force (as % of population) in Egypt, Arab Rep. in 1998 to that in 2001?
Make the answer very short. 0.91. What is the ratio of the Labor Force (as % of population) in Morocco in 1998 to that in 2001?
Make the answer very short. 0.99. What is the ratio of the Labor Force (as % of population) of Saudi Arabia in 1998 to that in 2001?
Ensure brevity in your answer.  0.91. What is the ratio of the Labor Force (as % of population) in Egypt, Arab Rep. in 1998 to that in 2002?
Provide a short and direct response. 0.89. What is the ratio of the Labor Force (as % of population) in Morocco in 1998 to that in 2002?
Your response must be concise. 0.98. What is the ratio of the Labor Force (as % of population) in Saudi Arabia in 1998 to that in 2002?
Give a very brief answer. 0.87. What is the ratio of the Labor Force (as % of population) in Egypt, Arab Rep. in 1999 to that in 2000?
Your answer should be compact. 0.98. What is the ratio of the Labor Force (as % of population) in Saudi Arabia in 1999 to that in 2000?
Make the answer very short. 0.95. What is the ratio of the Labor Force (as % of population) in Egypt, Arab Rep. in 1999 to that in 2001?
Provide a succinct answer. 0.96. What is the ratio of the Labor Force (as % of population) in Morocco in 1999 to that in 2001?
Your answer should be compact. 1.02. What is the ratio of the Labor Force (as % of population) in Saudi Arabia in 1999 to that in 2001?
Offer a very short reply. 0.92. What is the ratio of the Labor Force (as % of population) of Egypt, Arab Rep. in 1999 to that in 2002?
Your answer should be compact. 0.95. What is the ratio of the Labor Force (as % of population) in Morocco in 1999 to that in 2002?
Provide a succinct answer. 1.01. What is the ratio of the Labor Force (as % of population) in Saudi Arabia in 1999 to that in 2002?
Offer a very short reply. 0.88. What is the ratio of the Labor Force (as % of population) of Egypt, Arab Rep. in 2000 to that in 2001?
Keep it short and to the point. 0.98. What is the ratio of the Labor Force (as % of population) of Morocco in 2000 to that in 2001?
Provide a succinct answer. 1.02. What is the ratio of the Labor Force (as % of population) of Saudi Arabia in 2000 to that in 2001?
Provide a short and direct response. 0.97. What is the ratio of the Labor Force (as % of population) of Egypt, Arab Rep. in 2000 to that in 2002?
Ensure brevity in your answer.  0.97. What is the ratio of the Labor Force (as % of population) of Saudi Arabia in 2000 to that in 2002?
Give a very brief answer. 0.92. What is the ratio of the Labor Force (as % of population) of Egypt, Arab Rep. in 2001 to that in 2002?
Provide a succinct answer. 0.98. What is the ratio of the Labor Force (as % of population) of Saudi Arabia in 2001 to that in 2002?
Make the answer very short. 0.95. What is the difference between the highest and the second highest Labor Force (as % of population) in Egypt, Arab Rep.?
Make the answer very short. 3.33e+05. What is the difference between the highest and the second highest Labor Force (as % of population) in Morocco?
Offer a very short reply. 3.57e+04. What is the difference between the highest and the second highest Labor Force (as % of population) of Saudi Arabia?
Ensure brevity in your answer.  3.46e+05. What is the difference between the highest and the lowest Labor Force (as % of population) in Egypt, Arab Rep.?
Offer a terse response. 3.17e+06. What is the difference between the highest and the lowest Labor Force (as % of population) in Morocco?
Provide a short and direct response. 1.12e+06. What is the difference between the highest and the lowest Labor Force (as % of population) in Saudi Arabia?
Give a very brief answer. 1.27e+06. 